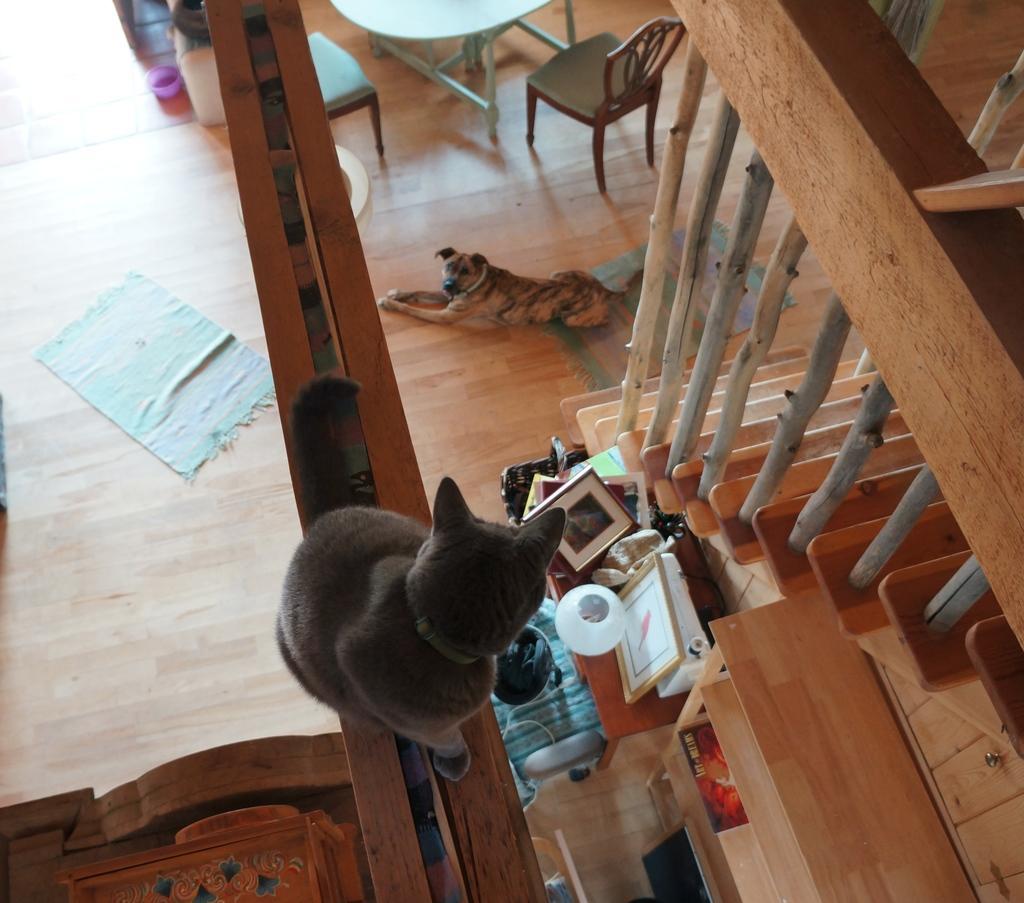Could you give a brief overview of what you see in this image? In this image I can see cat,dog. On the table there are frames. There is a chair and a stairs. 